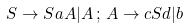<formula> <loc_0><loc_0><loc_500><loc_500>S \rightarrow S a A | A \, ; \, A \rightarrow c S d | b</formula> 